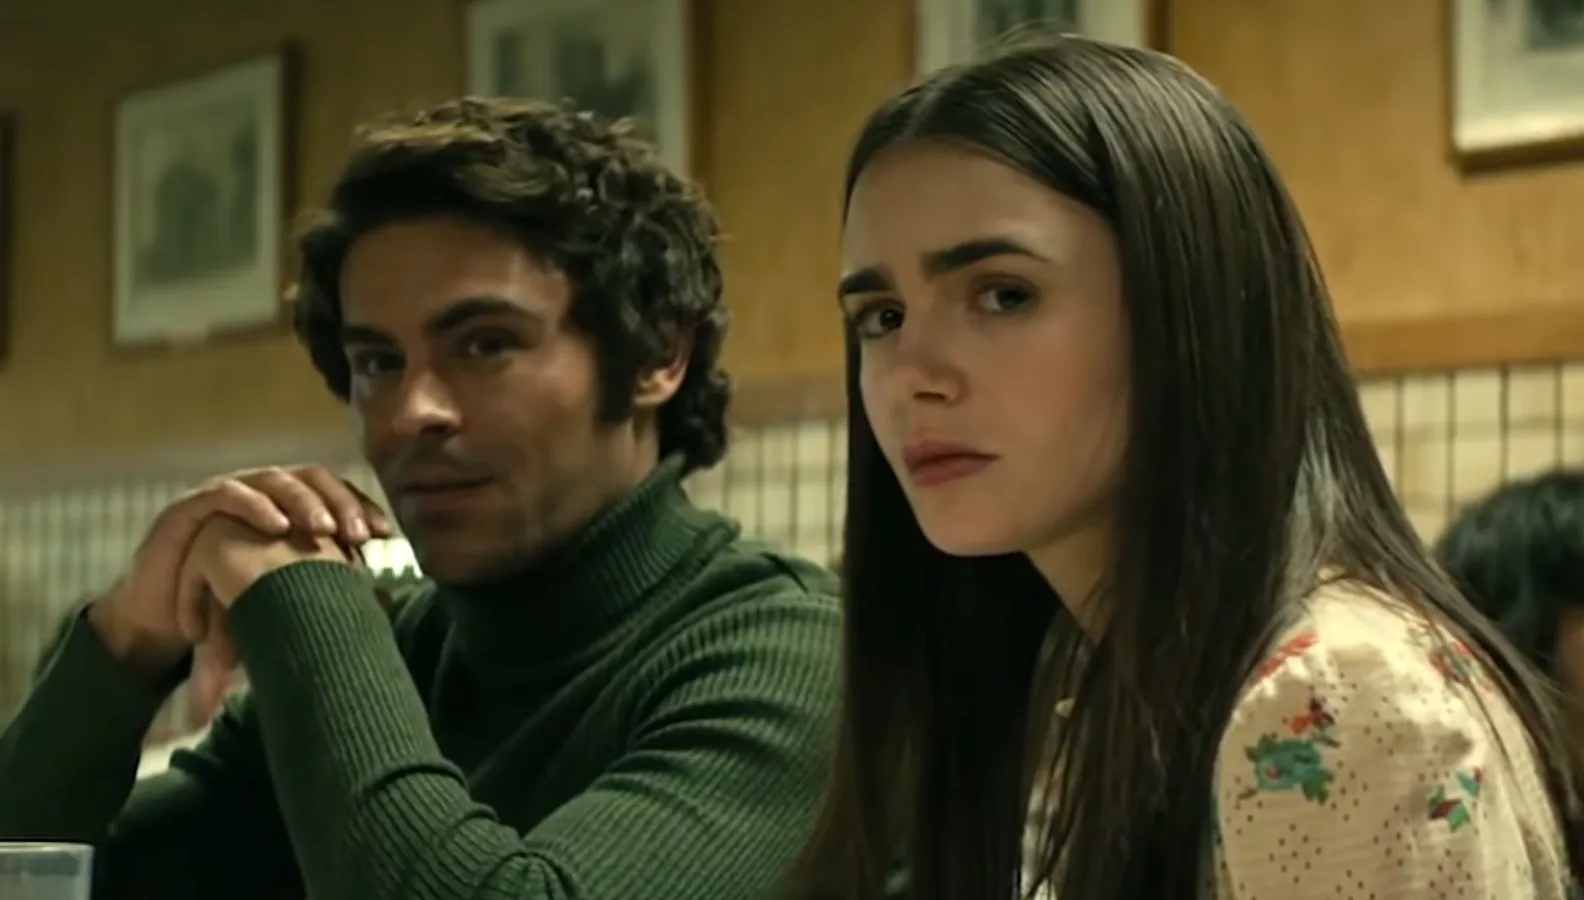Can you describe the emotions being portrayed by the characters in the image? The woman on the right projects a sense of seriousness, as evidenced by her furrowed brows and slightly pursed lips. She seems to be deeply immersed in thought or perhaps reacting to a critical piece of information. The man on the left has an equally serious demeanor, but his expression provides an additional layer of contemplation; his chin resting on clasped hands indicates he might be pondering over something significant or listening intently. The combined body language and expressions suggest a moment of gravity, where both characters are engaged in a meaningful and possibly challenging conversation. 